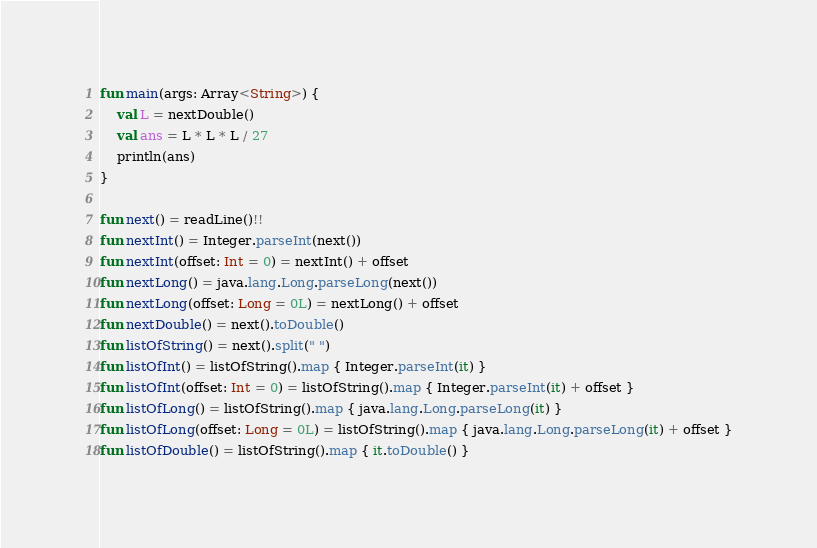Convert code to text. <code><loc_0><loc_0><loc_500><loc_500><_Kotlin_>fun main(args: Array<String>) {
    val L = nextDouble()
    val ans = L * L * L / 27
    println(ans)
}

fun next() = readLine()!!
fun nextInt() = Integer.parseInt(next())
fun nextInt(offset: Int = 0) = nextInt() + offset
fun nextLong() = java.lang.Long.parseLong(next())
fun nextLong(offset: Long = 0L) = nextLong() + offset
fun nextDouble() = next().toDouble()
fun listOfString() = next().split(" ")
fun listOfInt() = listOfString().map { Integer.parseInt(it) }
fun listOfInt(offset: Int = 0) = listOfString().map { Integer.parseInt(it) + offset }
fun listOfLong() = listOfString().map { java.lang.Long.parseLong(it) }
fun listOfLong(offset: Long = 0L) = listOfString().map { java.lang.Long.parseLong(it) + offset }
fun listOfDouble() = listOfString().map { it.toDouble() }
</code> 